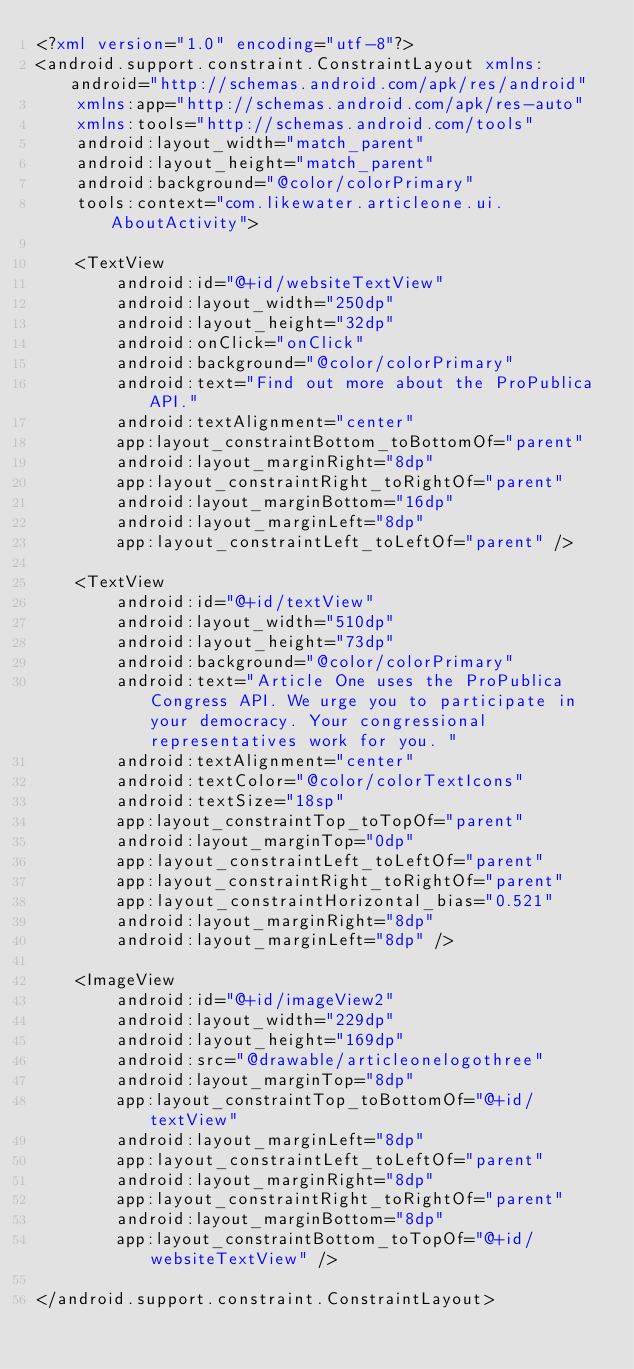<code> <loc_0><loc_0><loc_500><loc_500><_XML_><?xml version="1.0" encoding="utf-8"?>
<android.support.constraint.ConstraintLayout xmlns:android="http://schemas.android.com/apk/res/android"
    xmlns:app="http://schemas.android.com/apk/res-auto"
    xmlns:tools="http://schemas.android.com/tools"
    android:layout_width="match_parent"
    android:layout_height="match_parent"
    android:background="@color/colorPrimary"
    tools:context="com.likewater.articleone.ui.AboutActivity">

    <TextView
        android:id="@+id/websiteTextView"
        android:layout_width="250dp"
        android:layout_height="32dp"
        android:onClick="onClick"
        android:background="@color/colorPrimary"
        android:text="Find out more about the ProPublica API."
        android:textAlignment="center"
        app:layout_constraintBottom_toBottomOf="parent"
        android:layout_marginRight="8dp"
        app:layout_constraintRight_toRightOf="parent"
        android:layout_marginBottom="16dp"
        android:layout_marginLeft="8dp"
        app:layout_constraintLeft_toLeftOf="parent" />

    <TextView
        android:id="@+id/textView"
        android:layout_width="510dp"
        android:layout_height="73dp"
        android:background="@color/colorPrimary"
        android:text="Article One uses the ProPublica Congress API. We urge you to participate in your democracy. Your congressional representatives work for you. "
        android:textAlignment="center"
        android:textColor="@color/colorTextIcons"
        android:textSize="18sp"
        app:layout_constraintTop_toTopOf="parent"
        android:layout_marginTop="0dp"
        app:layout_constraintLeft_toLeftOf="parent"
        app:layout_constraintRight_toRightOf="parent"
        app:layout_constraintHorizontal_bias="0.521"
        android:layout_marginRight="8dp"
        android:layout_marginLeft="8dp" />

    <ImageView
        android:id="@+id/imageView2"
        android:layout_width="229dp"
        android:layout_height="169dp"
        android:src="@drawable/articleonelogothree"
        android:layout_marginTop="8dp"
        app:layout_constraintTop_toBottomOf="@+id/textView"
        android:layout_marginLeft="8dp"
        app:layout_constraintLeft_toLeftOf="parent"
        android:layout_marginRight="8dp"
        app:layout_constraintRight_toRightOf="parent"
        android:layout_marginBottom="8dp"
        app:layout_constraintBottom_toTopOf="@+id/websiteTextView" />

</android.support.constraint.ConstraintLayout></code> 